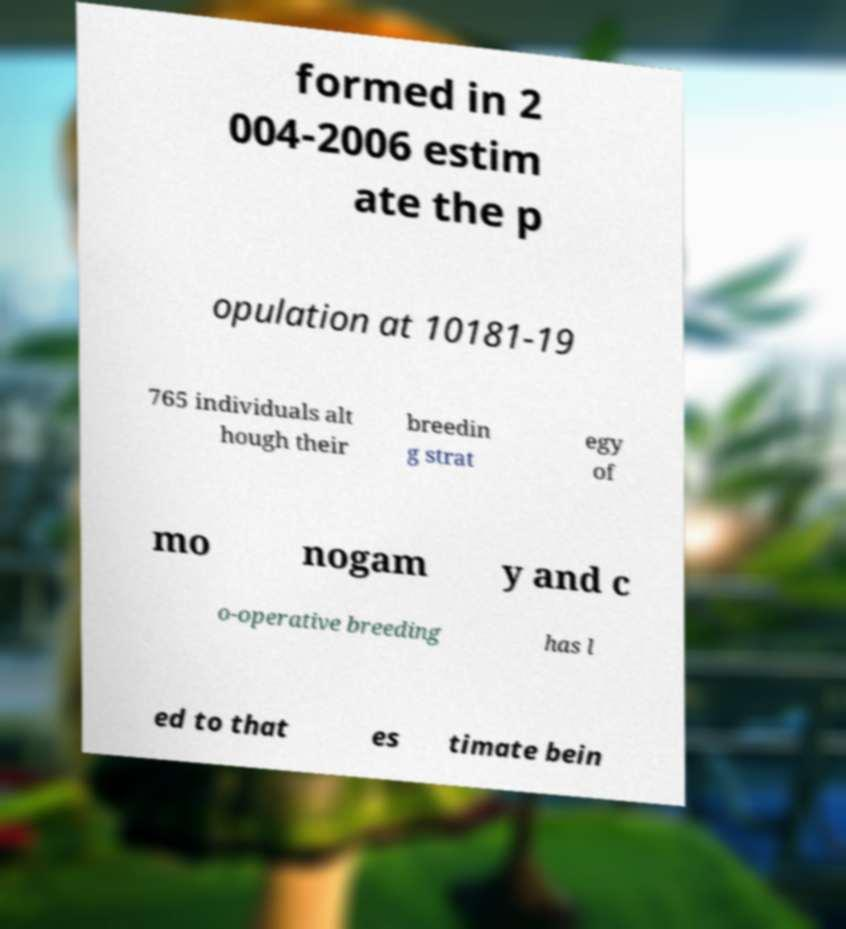Please read and relay the text visible in this image. What does it say? formed in 2 004-2006 estim ate the p opulation at 10181-19 765 individuals alt hough their breedin g strat egy of mo nogam y and c o-operative breeding has l ed to that es timate bein 